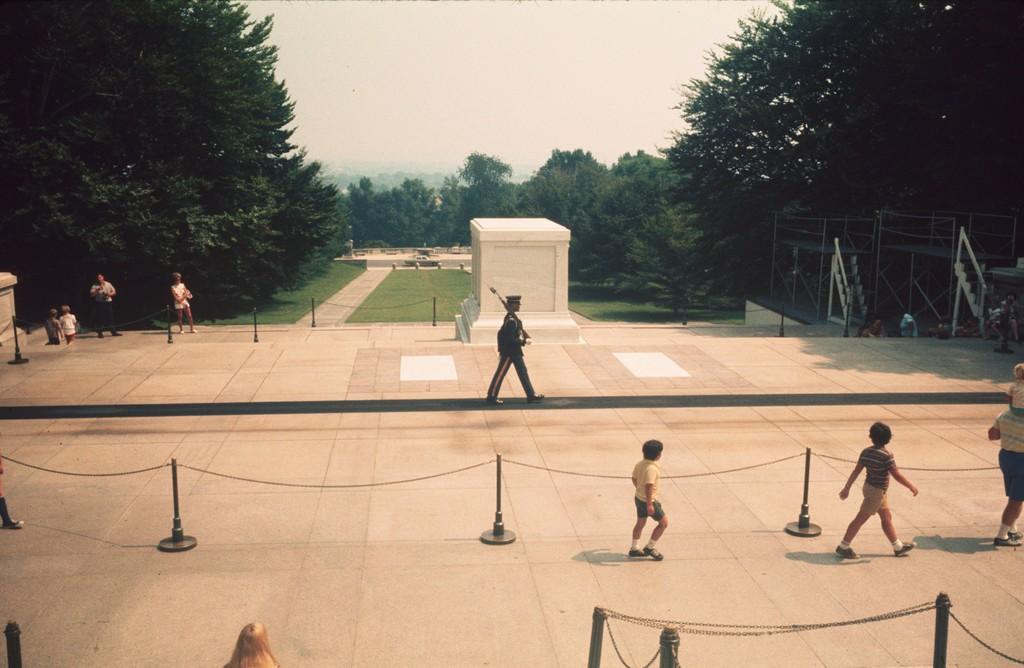Please provide a concise description of this image. In the image there is a person walking on the land holding a gun,on the right side there are three kids walking between fence, in the back there are trees with garden in the middle of it and above its sky. 